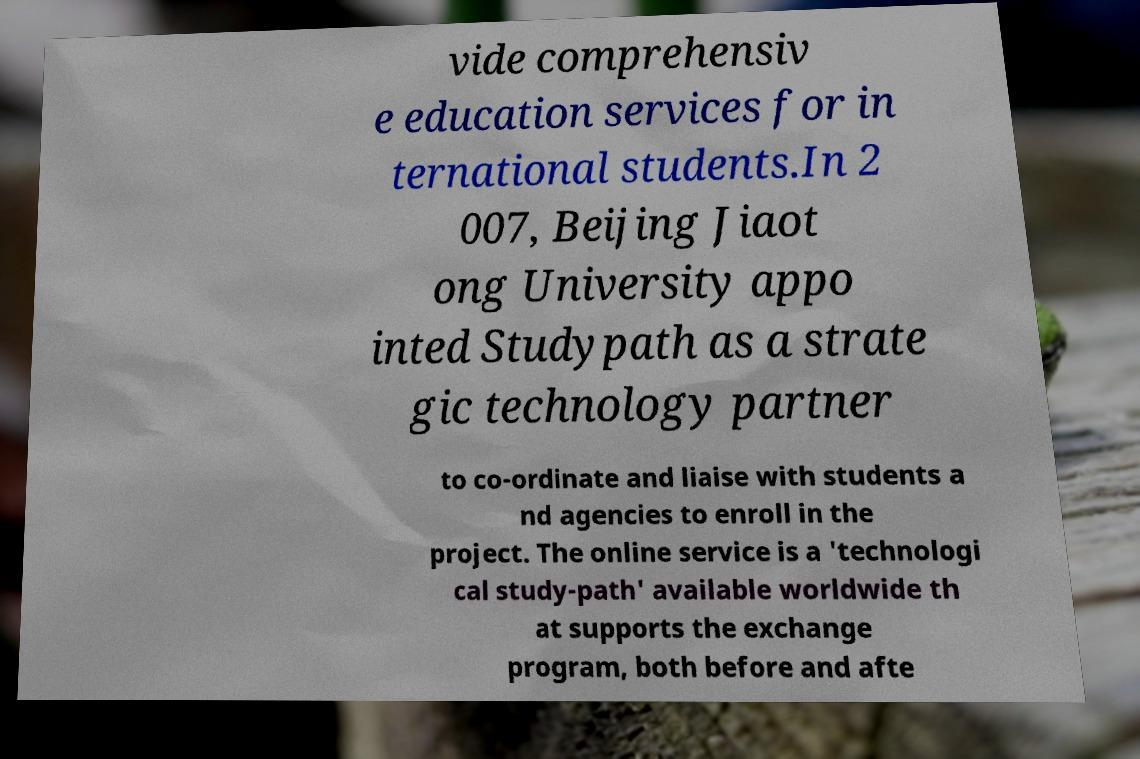Can you read and provide the text displayed in the image?This photo seems to have some interesting text. Can you extract and type it out for me? vide comprehensiv e education services for in ternational students.In 2 007, Beijing Jiaot ong University appo inted Studypath as a strate gic technology partner to co-ordinate and liaise with students a nd agencies to enroll in the project. The online service is a 'technologi cal study-path' available worldwide th at supports the exchange program, both before and afte 